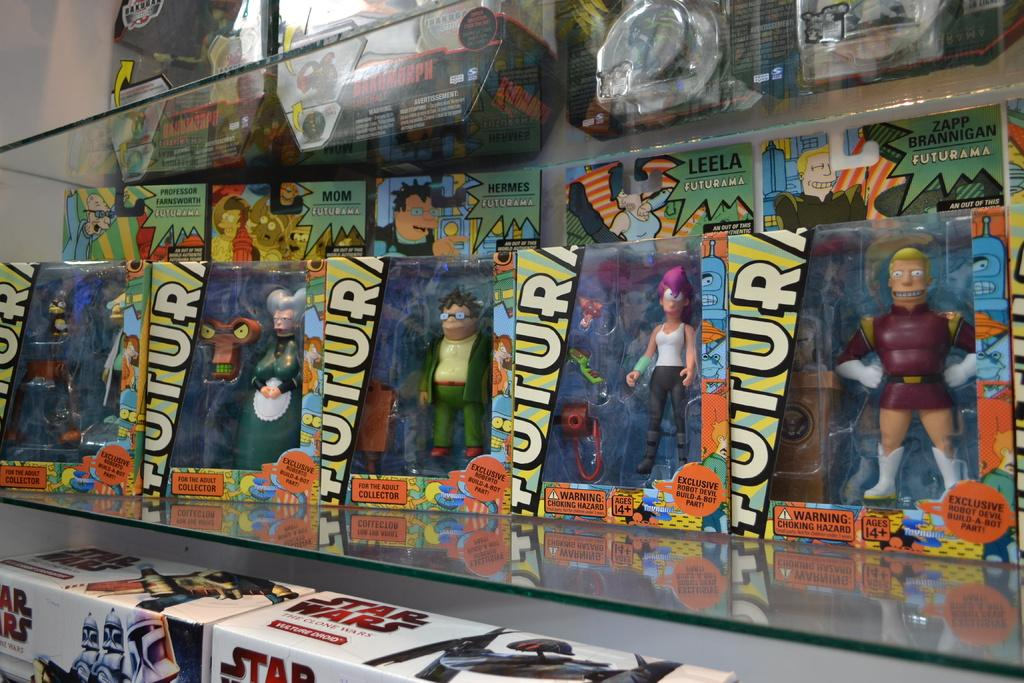<image>
Present a compact description of the photo's key features. A rack of Futurama action figures in a row. 